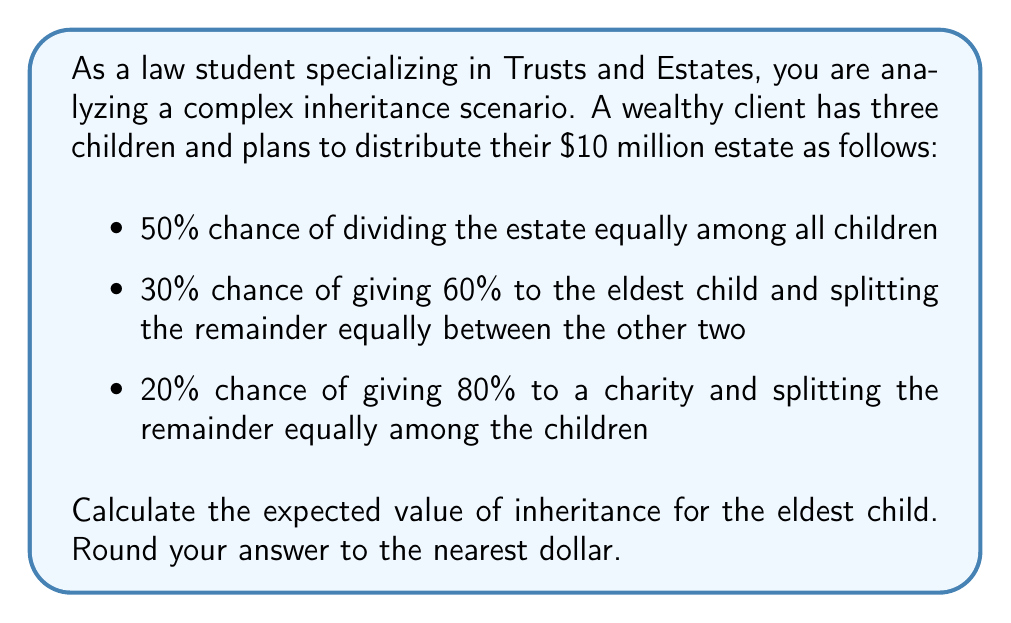Solve this math problem. To solve this problem, we need to calculate the expected value of the eldest child's inheritance based on the given probability distribution. Let's break it down step by step:

1. Scenario 1 (Equal division):
   Probability: $p_1 = 0.50$
   Inheritance: $I_1 = \frac{1}{3} \times \$10,000,000 = \$3,333,333.33$

2. Scenario 2 (60% to eldest, remainder split):
   Probability: $p_2 = 0.30$
   Inheritance: $I_2 = 0.60 \times \$10,000,000 = \$6,000,000$

3. Scenario 3 (80% to charity, remainder split):
   Probability: $p_3 = 0.20$
   Inheritance: $I_3 = \frac{1}{3} \times (0.20 \times \$10,000,000) = \$666,666.67$

Now, we calculate the expected value using the formula:

$$E(X) = \sum_{i=1}^{n} p_i \times I_i$$

Where $E(X)$ is the expected value, $p_i$ is the probability of each scenario, and $I_i$ is the inheritance amount for each scenario.

$$\begin{align*}
E(X) &= (0.50 \times \$3,333,333.33) + (0.30 \times \$6,000,000) + (0.20 \times \$666,666.67) \\
&= \$1,666,666.67 + \$1,800,000 + \$133,333.33 \\
&= \$3,600,000
\end{align*}$$
Answer: $3,600,000 